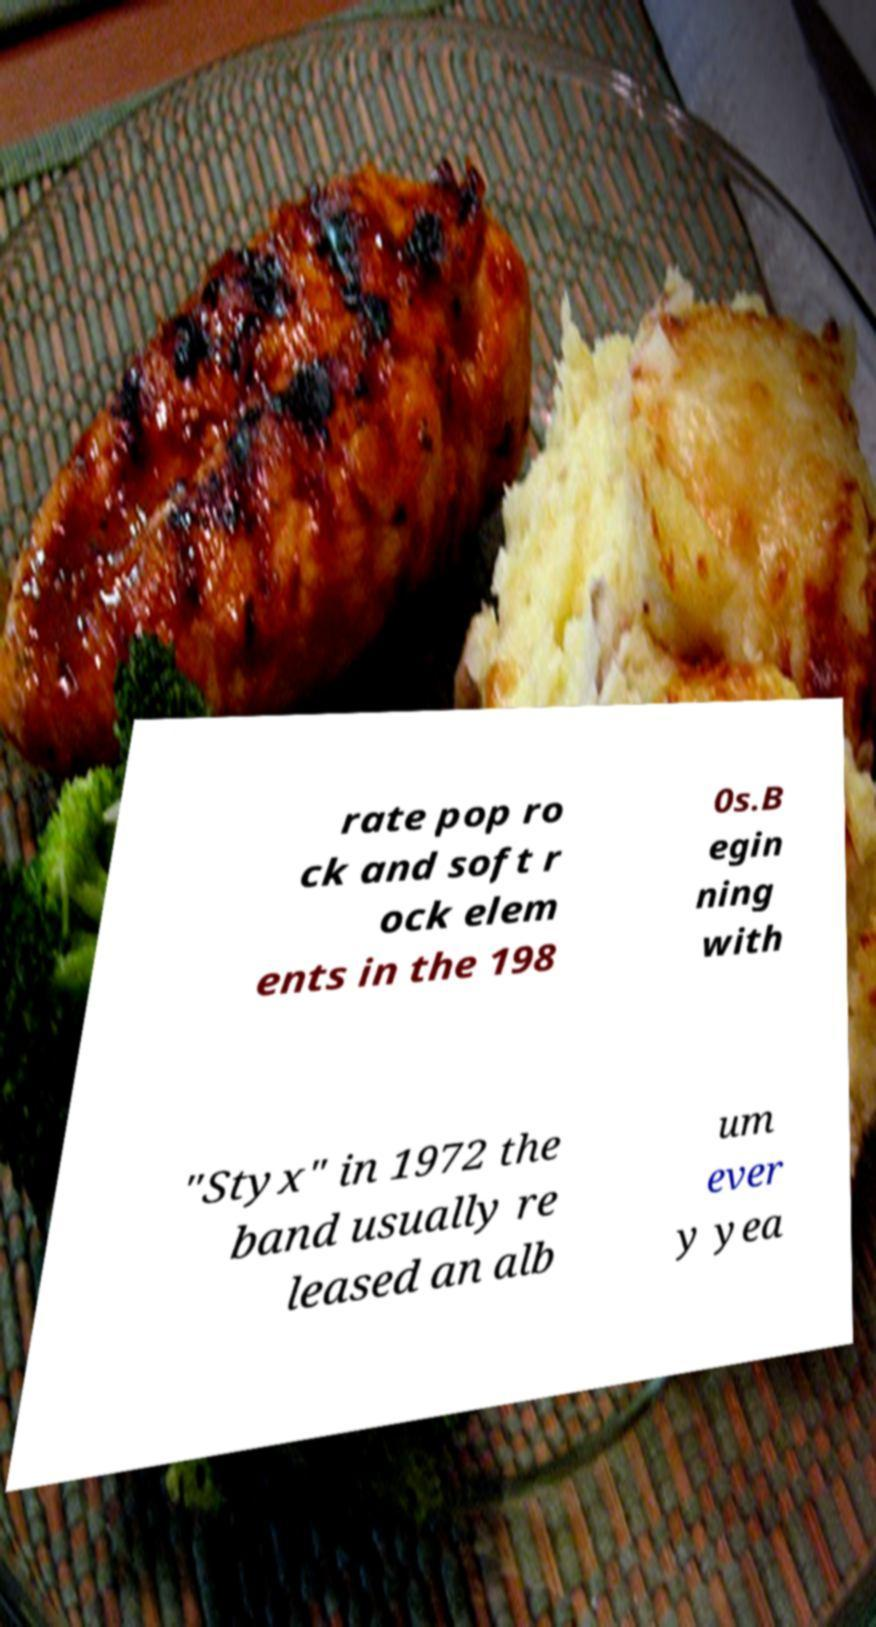There's text embedded in this image that I need extracted. Can you transcribe it verbatim? rate pop ro ck and soft r ock elem ents in the 198 0s.B egin ning with "Styx" in 1972 the band usually re leased an alb um ever y yea 